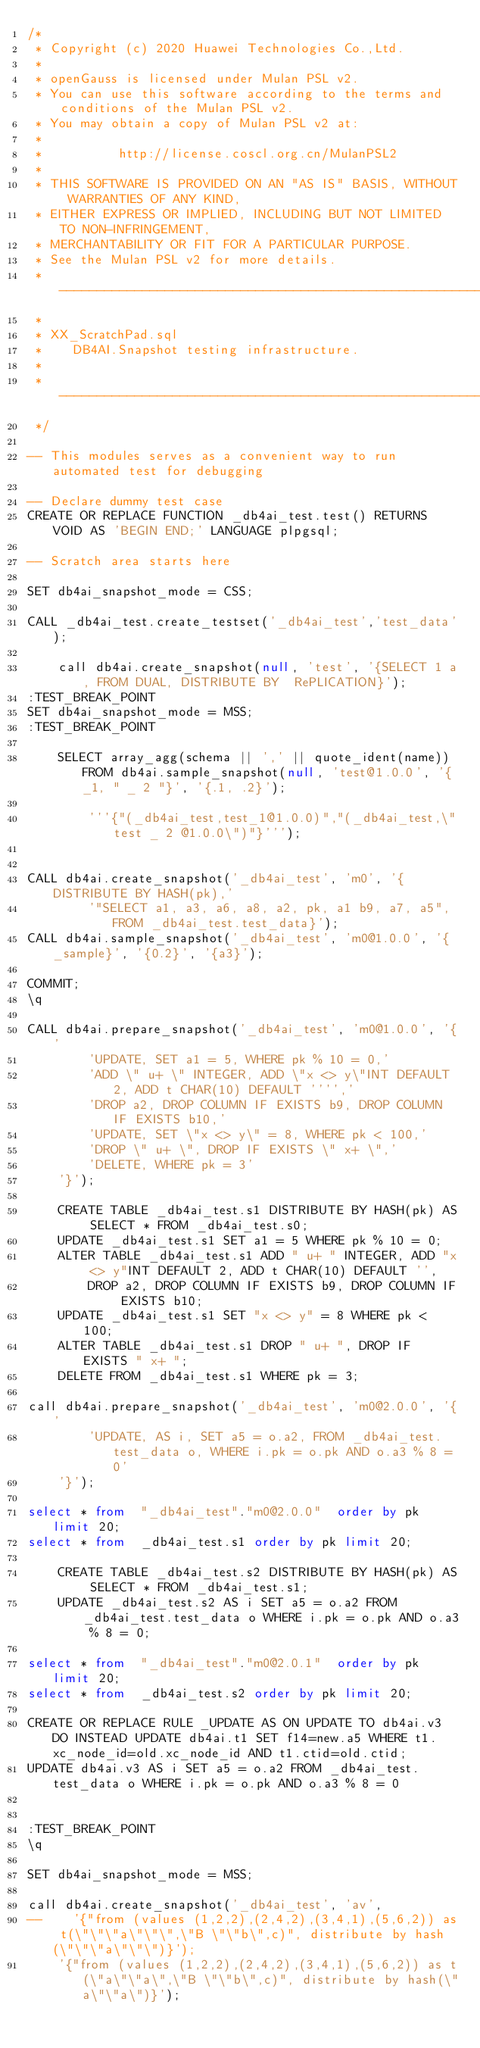<code> <loc_0><loc_0><loc_500><loc_500><_SQL_>/*
 * Copyright (c) 2020 Huawei Technologies Co.,Ltd.
 *
 * openGauss is licensed under Mulan PSL v2.
 * You can use this software according to the terms and conditions of the Mulan PSL v2.
 * You may obtain a copy of Mulan PSL v2 at:
 *
 *          http://license.coscl.org.cn/MulanPSL2
 *
 * THIS SOFTWARE IS PROVIDED ON AN "AS IS" BASIS, WITHOUT WARRANTIES OF ANY KIND,
 * EITHER EXPRESS OR IMPLIED, INCLUDING BUT NOT LIMITED TO NON-INFRINGEMENT,
 * MERCHANTABILITY OR FIT FOR A PARTICULAR PURPOSE.
 * See the Mulan PSL v2 for more details.
 * -------------------------------------------------------------------------
 *
 * XX_ScratchPad.sql
 *    DB4AI.Snapshot testing infrastructure.
 *
 * -------------------------------------------------------------------------
 */

-- This modules serves as a convenient way to run automated test for debugging

-- Declare dummy test case
CREATE OR REPLACE FUNCTION _db4ai_test.test() RETURNS VOID AS 'BEGIN END;' LANGUAGE plpgsql;

-- Scratch area starts here

SET db4ai_snapshot_mode = CSS;

CALL _db4ai_test.create_testset('_db4ai_test','test_data');

    call db4ai.create_snapshot(null, 'test', '{SELECT 1 a, FROM DUAL, DISTRIBUTE BY  RePLICATION}');
:TEST_BREAK_POINT
SET db4ai_snapshot_mode = MSS;
:TEST_BREAK_POINT

    SELECT array_agg(schema || ',' || quote_ident(name)) FROM db4ai.sample_snapshot(null, 'test@1.0.0', '{_1, " _ 2 "}', '{.1, .2}');

        '''{"(_db4ai_test,test_1@1.0.0)","(_db4ai_test,\"test _ 2 @1.0.0\")"}''');


CALL db4ai.create_snapshot('_db4ai_test', 'm0', '{DISTRIBUTE BY HASH(pk),'
        '"SELECT a1, a3, a6, a8, a2, pk, a1 b9, a7, a5", FROM _db4ai_test.test_data}');
CALL db4ai.sample_snapshot('_db4ai_test', 'm0@1.0.0', '{_sample}', '{0.2}', '{a3}');

COMMIT;
\q

CALL db4ai.prepare_snapshot('_db4ai_test', 'm0@1.0.0', '{'
        'UPDATE, SET a1 = 5, WHERE pk % 10 = 0,'
        'ADD \" u+ \" INTEGER, ADD \"x <> y\"INT DEFAULT 2, ADD t CHAR(10) DEFAULT '''','
        'DROP a2, DROP COLUMN IF EXISTS b9, DROP COLUMN IF EXISTS b10,'
        'UPDATE, SET \"x <> y\" = 8, WHERE pk < 100,'
        'DROP \" u+ \", DROP IF EXISTS \" x+ \",'
        'DELETE, WHERE pk = 3'
    '}');

    CREATE TABLE _db4ai_test.s1 DISTRIBUTE BY HASH(pk) AS SELECT * FROM _db4ai_test.s0;
    UPDATE _db4ai_test.s1 SET a1 = 5 WHERE pk % 10 = 0;
    ALTER TABLE _db4ai_test.s1 ADD " u+ " INTEGER, ADD "x <> y"INT DEFAULT 2, ADD t CHAR(10) DEFAULT '',
        DROP a2, DROP COLUMN IF EXISTS b9, DROP COLUMN IF EXISTS b10;
    UPDATE _db4ai_test.s1 SET "x <> y" = 8 WHERE pk < 100;
    ALTER TABLE _db4ai_test.s1 DROP " u+ ", DROP IF EXISTS " x+ ";
    DELETE FROM _db4ai_test.s1 WHERE pk = 3;

call db4ai.prepare_snapshot('_db4ai_test', 'm0@2.0.0', '{'
        'UPDATE, AS i, SET a5 = o.a2, FROM _db4ai_test.test_data o, WHERE i.pk = o.pk AND o.a3 % 8 = 0'
    '}');

select * from  "_db4ai_test"."m0@2.0.0"  order by pk limit 20;
select * from  _db4ai_test.s1 order by pk limit 20;

    CREATE TABLE _db4ai_test.s2 DISTRIBUTE BY HASH(pk) AS SELECT * FROM _db4ai_test.s1;
    UPDATE _db4ai_test.s2 AS i SET a5 = o.a2 FROM _db4ai_test.test_data o WHERE i.pk = o.pk AND o.a3 % 8 = 0;

select * from  "_db4ai_test"."m0@2.0.1"  order by pk limit 20;
select * from  _db4ai_test.s2 order by pk limit 20;

CREATE OR REPLACE RULE _UPDATE AS ON UPDATE TO db4ai.v3 DO INSTEAD UPDATE db4ai.t1 SET f14=new.a5 WHERE t1.xc_node_id=old.xc_node_id AND t1.ctid=old.ctid;
UPDATE db4ai.v3 AS i SET a5 = o.a2 FROM _db4ai_test.test_data o WHERE i.pk = o.pk AND o.a3 % 8 = 0


:TEST_BREAK_POINT
\q

SET db4ai_snapshot_mode = MSS;

call db4ai.create_snapshot('_db4ai_test', 'av',
--    '{"from (values (1,2,2),(2,4,2),(3,4,1),(5,6,2)) as t(\"\"\"a\"\"\",\"B \"\"b\",c)", distribute by hash(\"\"\"a\"\"\")}');
    '{"from (values (1,2,2),(2,4,2),(3,4,1),(5,6,2)) as t(\"a\"\"a\",\"B \"\"b\",c)", distribute by hash(\"a\"\"a\")}');
</code> 